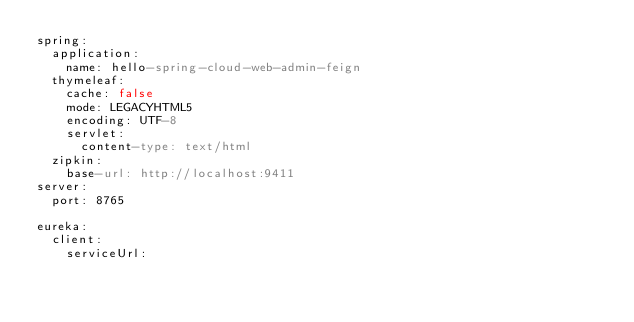<code> <loc_0><loc_0><loc_500><loc_500><_YAML_>spring:
  application:
    name: hello-spring-cloud-web-admin-feign
  thymeleaf:
    cache: false
    mode: LEGACYHTML5
    encoding: UTF-8
    servlet:
      content-type: text/html
  zipkin:
    base-url: http://localhost:9411
server:
  port: 8765

eureka:
  client:
    serviceUrl:</code> 